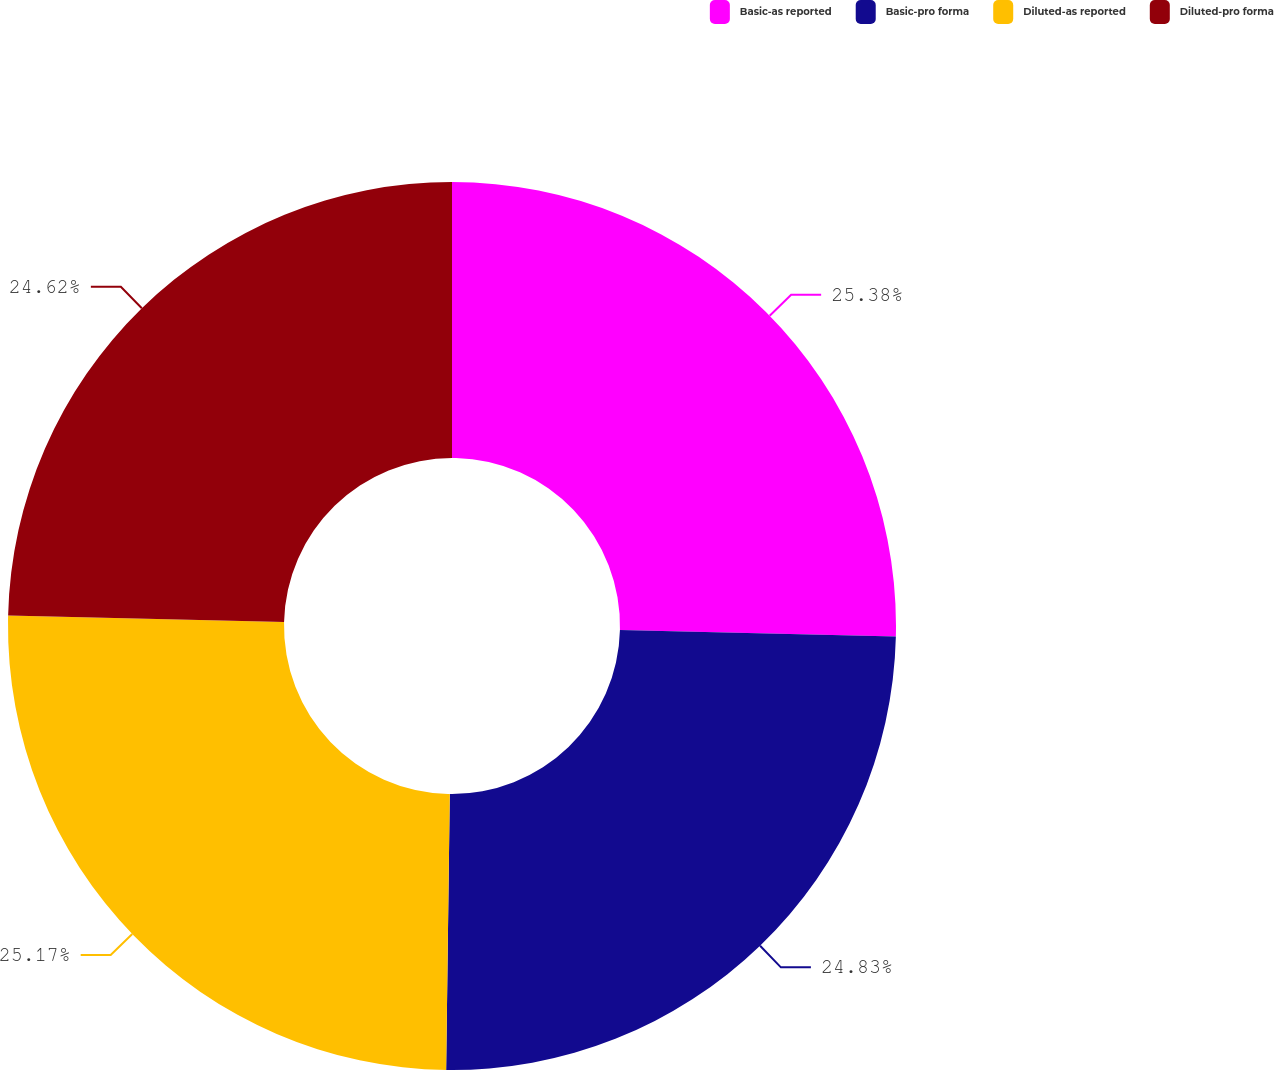Convert chart. <chart><loc_0><loc_0><loc_500><loc_500><pie_chart><fcel>Basic-as reported<fcel>Basic-pro forma<fcel>Diluted-as reported<fcel>Diluted-pro forma<nl><fcel>25.38%<fcel>24.83%<fcel>25.17%<fcel>24.62%<nl></chart> 